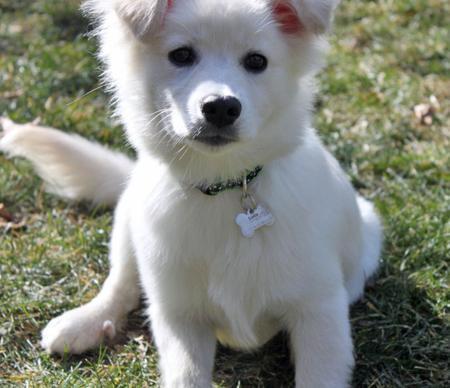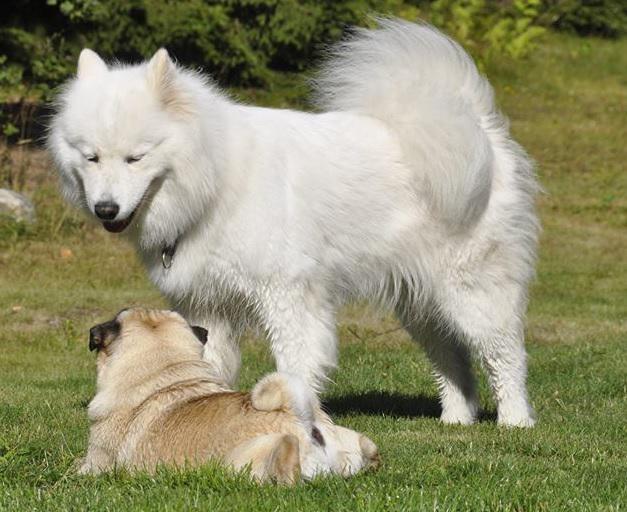The first image is the image on the left, the second image is the image on the right. Given the left and right images, does the statement "There are exactly three dogs." hold true? Answer yes or no. Yes. The first image is the image on the left, the second image is the image on the right. Analyze the images presented: Is the assertion "there ia a puppy sitting on something that isn't grass" valid? Answer yes or no. No. 